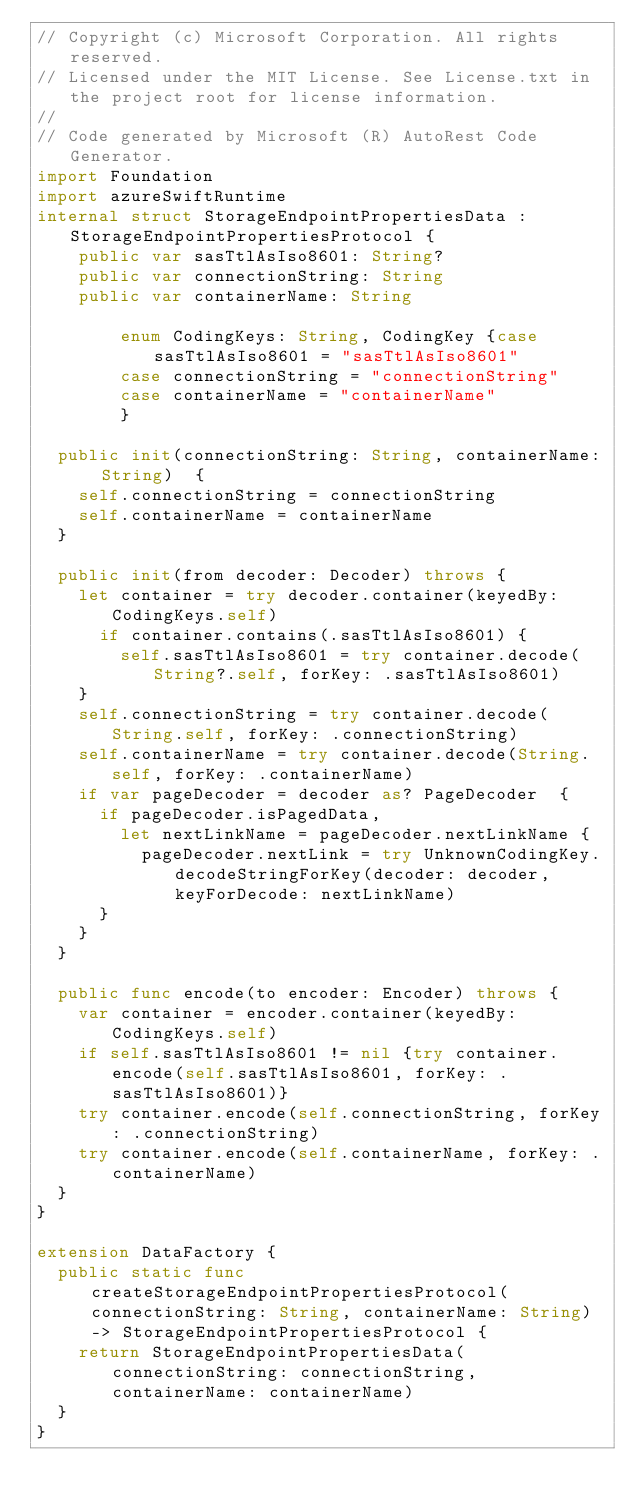<code> <loc_0><loc_0><loc_500><loc_500><_Swift_>// Copyright (c) Microsoft Corporation. All rights reserved.
// Licensed under the MIT License. See License.txt in the project root for license information.
//
// Code generated by Microsoft (R) AutoRest Code Generator.
import Foundation
import azureSwiftRuntime
internal struct StorageEndpointPropertiesData : StorageEndpointPropertiesProtocol {
    public var sasTtlAsIso8601: String?
    public var connectionString: String
    public var containerName: String

        enum CodingKeys: String, CodingKey {case sasTtlAsIso8601 = "sasTtlAsIso8601"
        case connectionString = "connectionString"
        case containerName = "containerName"
        }

  public init(connectionString: String, containerName: String)  {
    self.connectionString = connectionString
    self.containerName = containerName
  }

  public init(from decoder: Decoder) throws {
    let container = try decoder.container(keyedBy: CodingKeys.self)
      if container.contains(.sasTtlAsIso8601) {
        self.sasTtlAsIso8601 = try container.decode(String?.self, forKey: .sasTtlAsIso8601)
    }
    self.connectionString = try container.decode(String.self, forKey: .connectionString)
    self.containerName = try container.decode(String.self, forKey: .containerName)
    if var pageDecoder = decoder as? PageDecoder  {
      if pageDecoder.isPagedData,
        let nextLinkName = pageDecoder.nextLinkName {
          pageDecoder.nextLink = try UnknownCodingKey.decodeStringForKey(decoder: decoder, keyForDecode: nextLinkName)
      }
    }
  }

  public func encode(to encoder: Encoder) throws {
    var container = encoder.container(keyedBy: CodingKeys.self)
    if self.sasTtlAsIso8601 != nil {try container.encode(self.sasTtlAsIso8601, forKey: .sasTtlAsIso8601)}
    try container.encode(self.connectionString, forKey: .connectionString)
    try container.encode(self.containerName, forKey: .containerName)
  }
}

extension DataFactory {
  public static func createStorageEndpointPropertiesProtocol(connectionString: String, containerName: String) -> StorageEndpointPropertiesProtocol {
    return StorageEndpointPropertiesData(connectionString: connectionString, containerName: containerName)
  }
}
</code> 